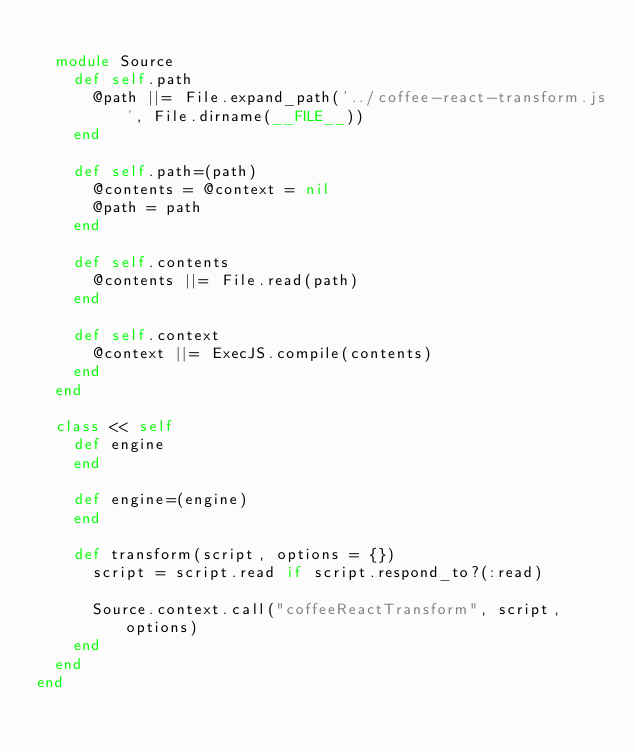<code> <loc_0><loc_0><loc_500><loc_500><_Ruby_>
  module Source
    def self.path
      @path ||= File.expand_path('../coffee-react-transform.js', File.dirname(__FILE__))
    end

    def self.path=(path)
      @contents = @context = nil
      @path = path
    end

    def self.contents
      @contents ||= File.read(path)
    end

    def self.context
      @context ||= ExecJS.compile(contents)
    end
  end

  class << self
    def engine
    end

    def engine=(engine)
    end

    def transform(script, options = {})
      script = script.read if script.respond_to?(:read)

      Source.context.call("coffeeReactTransform", script, options)
    end
  end
end
</code> 